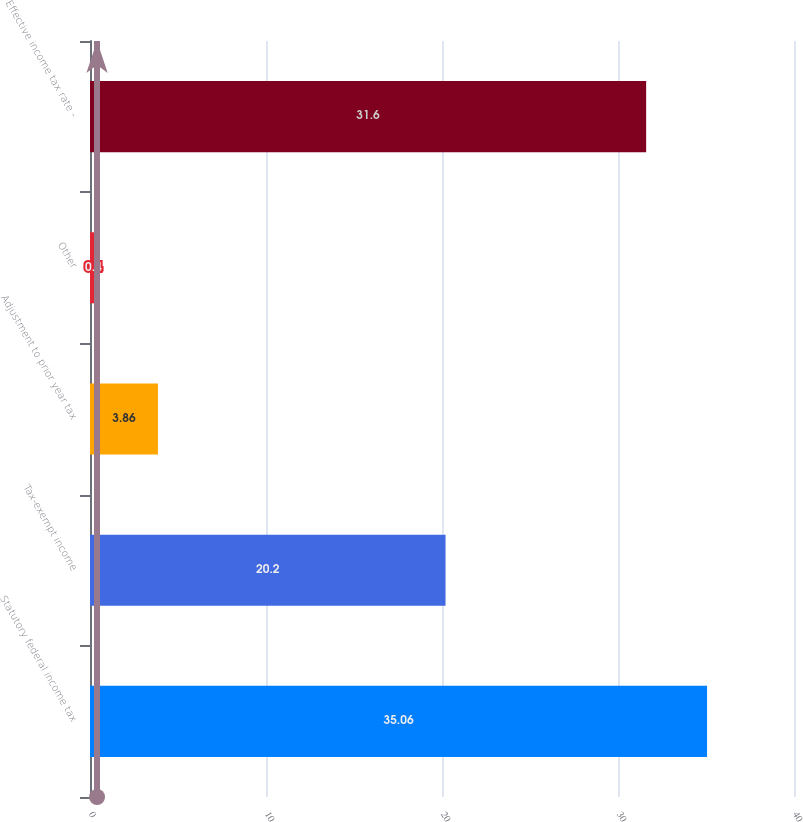Convert chart to OTSL. <chart><loc_0><loc_0><loc_500><loc_500><bar_chart><fcel>Statutory federal income tax<fcel>Tax-exempt income<fcel>Adjustment to prior year tax<fcel>Other<fcel>Effective income tax rate -<nl><fcel>35.06<fcel>20.2<fcel>3.86<fcel>0.4<fcel>31.6<nl></chart> 